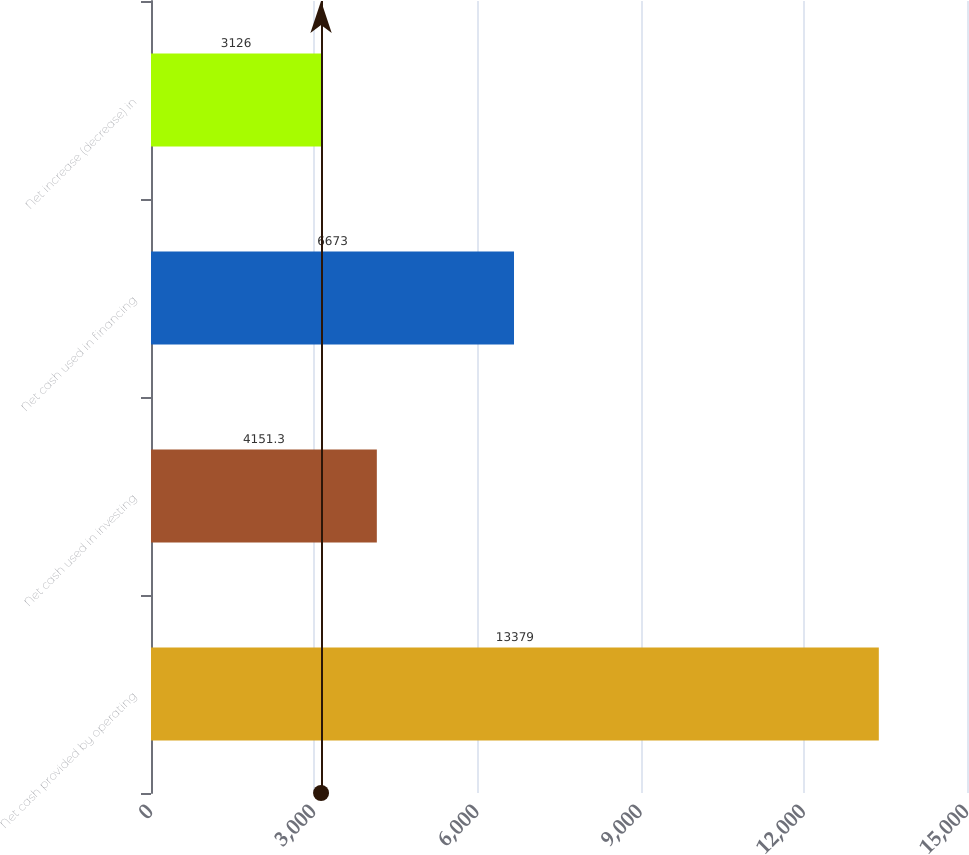Convert chart to OTSL. <chart><loc_0><loc_0><loc_500><loc_500><bar_chart><fcel>Net cash provided by operating<fcel>Net cash used in investing<fcel>Net cash used in financing<fcel>Net increase (decrease) in<nl><fcel>13379<fcel>4151.3<fcel>6673<fcel>3126<nl></chart> 